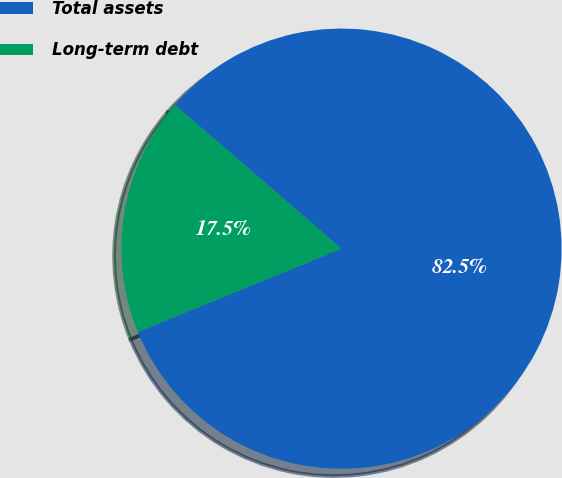<chart> <loc_0><loc_0><loc_500><loc_500><pie_chart><fcel>Total assets<fcel>Long-term debt<nl><fcel>82.49%<fcel>17.51%<nl></chart> 